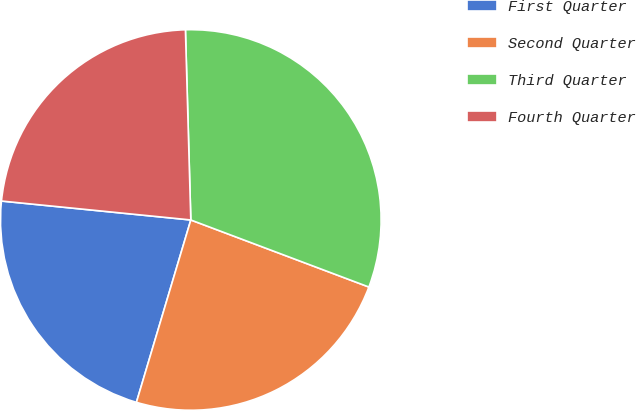<chart> <loc_0><loc_0><loc_500><loc_500><pie_chart><fcel>First Quarter<fcel>Second Quarter<fcel>Third Quarter<fcel>Fourth Quarter<nl><fcel>21.97%<fcel>23.88%<fcel>31.18%<fcel>22.96%<nl></chart> 